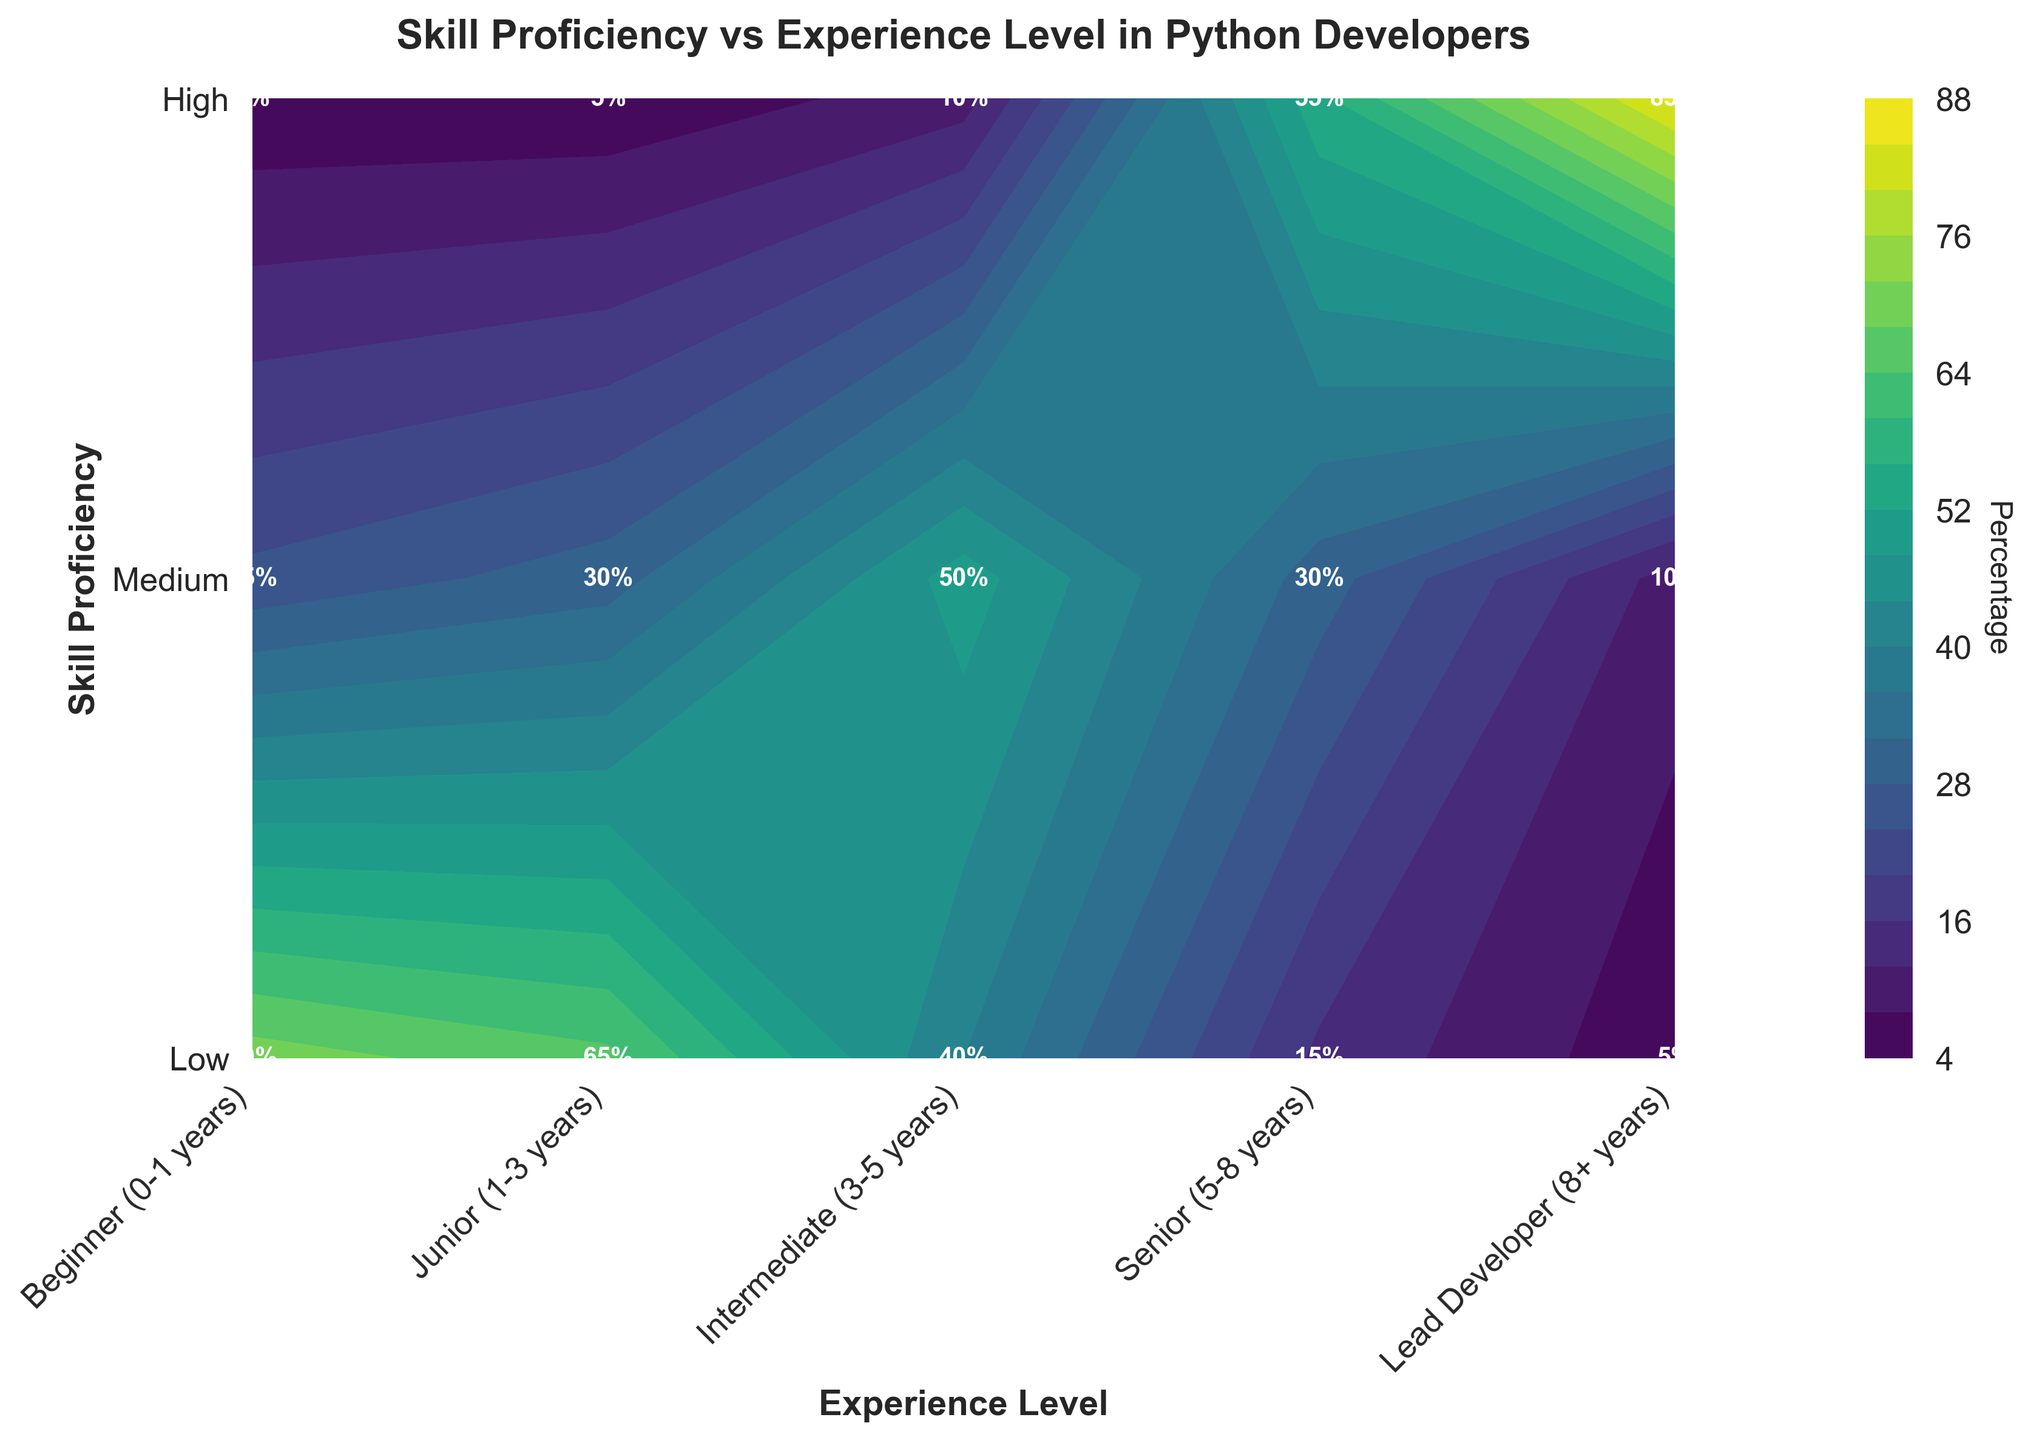What is the title of the contour plot? The title is usually placed at the top of the plot. In this case, it reads "Skill Proficiency vs Experience Level in Python Developers."
Answer: Skill Proficiency vs Experience Level in Python Developers What does the color bar represent in the contour plot? The color bar typically indicates the range and meaning of colors used in the contour plot. Here, it is labeled 'Percentage,' showing the percentage of Python developers with particular skill levels across different experience levels.
Answer: Percentage Which experience level has the highest percentage of developers with high skill proficiency? Look at the highest row labeled 'High' and find the highest value. The highest percentage (85%) is under the 'Lead Developer (8+ years)' column.
Answer: Lead Developer (8+ years) Between 'Senior (5-8 years)' and 'Junior (1-3 years)' experience levels, which has a higher percentage of developers at a low skill level? Compare the values in the 'Low' row for 'Senior (5-8 years)' (15%) and 'Junior (1-3 years)' (65%). The 'Junior (1-3 years)' level has a higher percentage.
Answer: Junior (1-3 years) What is the total percentage of developers with medium skill proficiency across all experience levels? Sum the values in the 'Medium' row: 25 (Beginner) + 30 (Junior) + 50 (Intermediate) + 30 (Senior) + 10 (Lead Developer) = 145.
Answer: 145 What is the difference in percentage between intermediate developers (3-5 years) with medium and high skill proficiency? Subtract the values for intermediate developers in the 'High' skill proficiency (10%) from the 'Medium' skill proficiency (50%): 50 - 10 = 40.
Answer: 40 How many experience levels are represented in the plot? Count the number of unique experience levels listed along the x-axis. In this plot, there are five: Beginner (0-1 years), Junior (1-3 years), Intermediate (3-5 years), Senior (5-8 years), and Lead Developer (8+ years).
Answer: Five Which skill proficiency level has the lowest overall percentage of developers? Inspect each row's values and find the smallest. The 'Low' skill proficiency has the smallest values overall, with very low numbers especially in the 'Lead Developer (8+ years)' column.
Answer: Low What percentage of lead developers have low skill proficiency? Look at the intersection of 'Lead Developer (8+ years)' and 'Low' and read the value, which is 5%.
Answer: 5 Which skill proficiency level shows the highest increase in percentage from beginner to lead developer? Calculate the difference for each skill level from beginner to lead developer and identify the largest increase. For 'Low': 70% - 5% = 65%. For 'Medium': 25% - 10% = 15%. For 'High': 5% - 85% = -80%. The 'Low' skill proficiency shows the highest increase.
Answer: Low 